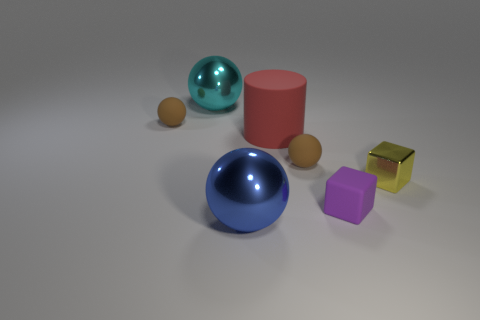What number of other things are there of the same material as the big cyan thing
Make the answer very short. 2. Do the big red cylinder that is to the left of the small yellow block and the small brown ball on the left side of the big cyan metallic thing have the same material?
Make the answer very short. Yes. What shape is the purple object that is the same material as the large red object?
Offer a very short reply. Cube. Are there any other things of the same color as the small metallic block?
Keep it short and to the point. No. What number of tiny purple rubber objects are there?
Give a very brief answer. 1. The metallic object that is both behind the blue shiny thing and to the right of the large cyan metallic sphere has what shape?
Your response must be concise. Cube. There is a small thing left of the big metal sphere that is in front of the large metal thing behind the big blue metallic sphere; what shape is it?
Ensure brevity in your answer.  Sphere. What is the thing that is both on the left side of the cylinder and in front of the small yellow metal thing made of?
Your answer should be compact. Metal. How many red rubber objects have the same size as the cyan shiny sphere?
Provide a short and direct response. 1. How many shiny things are either purple cubes or yellow balls?
Offer a terse response. 0. 